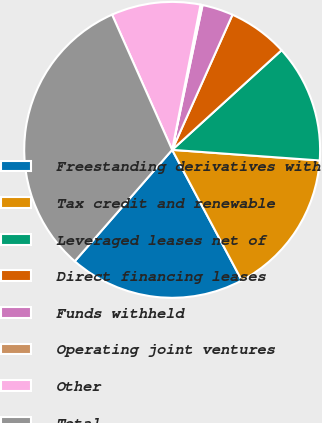Convert chart. <chart><loc_0><loc_0><loc_500><loc_500><pie_chart><fcel>Freestanding derivatives with<fcel>Tax credit and renewable<fcel>Leveraged leases net of<fcel>Direct financing leases<fcel>Funds withheld<fcel>Operating joint ventures<fcel>Other<fcel>Total<nl><fcel>19.23%<fcel>16.06%<fcel>12.9%<fcel>6.56%<fcel>3.39%<fcel>0.22%<fcel>9.73%<fcel>31.91%<nl></chart> 